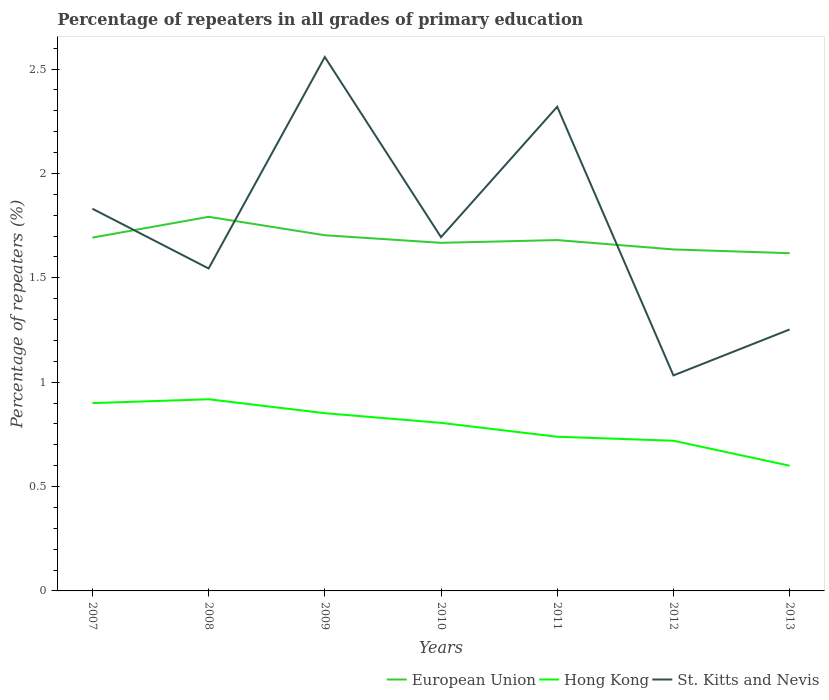Does the line corresponding to European Union intersect with the line corresponding to St. Kitts and Nevis?
Your response must be concise. Yes. Is the number of lines equal to the number of legend labels?
Give a very brief answer. Yes. Across all years, what is the maximum percentage of repeaters in St. Kitts and Nevis?
Your answer should be very brief. 1.03. What is the total percentage of repeaters in European Union in the graph?
Provide a short and direct response. 0.09. What is the difference between the highest and the second highest percentage of repeaters in European Union?
Your answer should be very brief. 0.17. How many lines are there?
Ensure brevity in your answer.  3. How many years are there in the graph?
Your answer should be very brief. 7. Where does the legend appear in the graph?
Keep it short and to the point. Bottom right. What is the title of the graph?
Offer a terse response. Percentage of repeaters in all grades of primary education. Does "Timor-Leste" appear as one of the legend labels in the graph?
Offer a terse response. No. What is the label or title of the Y-axis?
Make the answer very short. Percentage of repeaters (%). What is the Percentage of repeaters (%) in European Union in 2007?
Keep it short and to the point. 1.69. What is the Percentage of repeaters (%) of Hong Kong in 2007?
Offer a terse response. 0.9. What is the Percentage of repeaters (%) in St. Kitts and Nevis in 2007?
Give a very brief answer. 1.83. What is the Percentage of repeaters (%) in European Union in 2008?
Provide a short and direct response. 1.79. What is the Percentage of repeaters (%) of Hong Kong in 2008?
Ensure brevity in your answer.  0.92. What is the Percentage of repeaters (%) of St. Kitts and Nevis in 2008?
Make the answer very short. 1.54. What is the Percentage of repeaters (%) in European Union in 2009?
Your response must be concise. 1.7. What is the Percentage of repeaters (%) in Hong Kong in 2009?
Ensure brevity in your answer.  0.85. What is the Percentage of repeaters (%) in St. Kitts and Nevis in 2009?
Keep it short and to the point. 2.56. What is the Percentage of repeaters (%) in European Union in 2010?
Provide a short and direct response. 1.67. What is the Percentage of repeaters (%) of Hong Kong in 2010?
Give a very brief answer. 0.81. What is the Percentage of repeaters (%) of St. Kitts and Nevis in 2010?
Make the answer very short. 1.69. What is the Percentage of repeaters (%) in European Union in 2011?
Give a very brief answer. 1.68. What is the Percentage of repeaters (%) in Hong Kong in 2011?
Provide a succinct answer. 0.74. What is the Percentage of repeaters (%) in St. Kitts and Nevis in 2011?
Your answer should be compact. 2.32. What is the Percentage of repeaters (%) of European Union in 2012?
Give a very brief answer. 1.64. What is the Percentage of repeaters (%) in Hong Kong in 2012?
Provide a succinct answer. 0.72. What is the Percentage of repeaters (%) in St. Kitts and Nevis in 2012?
Offer a terse response. 1.03. What is the Percentage of repeaters (%) in European Union in 2013?
Give a very brief answer. 1.62. What is the Percentage of repeaters (%) in Hong Kong in 2013?
Your response must be concise. 0.6. What is the Percentage of repeaters (%) of St. Kitts and Nevis in 2013?
Your answer should be compact. 1.25. Across all years, what is the maximum Percentage of repeaters (%) in European Union?
Your answer should be compact. 1.79. Across all years, what is the maximum Percentage of repeaters (%) in Hong Kong?
Offer a terse response. 0.92. Across all years, what is the maximum Percentage of repeaters (%) of St. Kitts and Nevis?
Your response must be concise. 2.56. Across all years, what is the minimum Percentage of repeaters (%) of European Union?
Your answer should be very brief. 1.62. Across all years, what is the minimum Percentage of repeaters (%) in Hong Kong?
Provide a short and direct response. 0.6. Across all years, what is the minimum Percentage of repeaters (%) in St. Kitts and Nevis?
Offer a terse response. 1.03. What is the total Percentage of repeaters (%) of European Union in the graph?
Provide a short and direct response. 11.79. What is the total Percentage of repeaters (%) of Hong Kong in the graph?
Your answer should be compact. 5.53. What is the total Percentage of repeaters (%) in St. Kitts and Nevis in the graph?
Offer a very short reply. 12.23. What is the difference between the Percentage of repeaters (%) in European Union in 2007 and that in 2008?
Provide a short and direct response. -0.1. What is the difference between the Percentage of repeaters (%) in Hong Kong in 2007 and that in 2008?
Offer a terse response. -0.02. What is the difference between the Percentage of repeaters (%) of St. Kitts and Nevis in 2007 and that in 2008?
Ensure brevity in your answer.  0.29. What is the difference between the Percentage of repeaters (%) of European Union in 2007 and that in 2009?
Ensure brevity in your answer.  -0.01. What is the difference between the Percentage of repeaters (%) in Hong Kong in 2007 and that in 2009?
Your answer should be compact. 0.05. What is the difference between the Percentage of repeaters (%) in St. Kitts and Nevis in 2007 and that in 2009?
Offer a terse response. -0.73. What is the difference between the Percentage of repeaters (%) of European Union in 2007 and that in 2010?
Your answer should be compact. 0.03. What is the difference between the Percentage of repeaters (%) of Hong Kong in 2007 and that in 2010?
Give a very brief answer. 0.09. What is the difference between the Percentage of repeaters (%) in St. Kitts and Nevis in 2007 and that in 2010?
Your answer should be compact. 0.14. What is the difference between the Percentage of repeaters (%) of European Union in 2007 and that in 2011?
Your answer should be very brief. 0.01. What is the difference between the Percentage of repeaters (%) in Hong Kong in 2007 and that in 2011?
Ensure brevity in your answer.  0.16. What is the difference between the Percentage of repeaters (%) in St. Kitts and Nevis in 2007 and that in 2011?
Ensure brevity in your answer.  -0.49. What is the difference between the Percentage of repeaters (%) of European Union in 2007 and that in 2012?
Your answer should be very brief. 0.06. What is the difference between the Percentage of repeaters (%) of Hong Kong in 2007 and that in 2012?
Your answer should be very brief. 0.18. What is the difference between the Percentage of repeaters (%) in St. Kitts and Nevis in 2007 and that in 2012?
Provide a short and direct response. 0.8. What is the difference between the Percentage of repeaters (%) of European Union in 2007 and that in 2013?
Your response must be concise. 0.07. What is the difference between the Percentage of repeaters (%) of Hong Kong in 2007 and that in 2013?
Your response must be concise. 0.3. What is the difference between the Percentage of repeaters (%) in St. Kitts and Nevis in 2007 and that in 2013?
Make the answer very short. 0.58. What is the difference between the Percentage of repeaters (%) in European Union in 2008 and that in 2009?
Ensure brevity in your answer.  0.09. What is the difference between the Percentage of repeaters (%) in Hong Kong in 2008 and that in 2009?
Your answer should be very brief. 0.07. What is the difference between the Percentage of repeaters (%) of St. Kitts and Nevis in 2008 and that in 2009?
Provide a succinct answer. -1.01. What is the difference between the Percentage of repeaters (%) in European Union in 2008 and that in 2010?
Your answer should be compact. 0.12. What is the difference between the Percentage of repeaters (%) in Hong Kong in 2008 and that in 2010?
Offer a terse response. 0.11. What is the difference between the Percentage of repeaters (%) in St. Kitts and Nevis in 2008 and that in 2010?
Make the answer very short. -0.15. What is the difference between the Percentage of repeaters (%) of European Union in 2008 and that in 2011?
Offer a terse response. 0.11. What is the difference between the Percentage of repeaters (%) of Hong Kong in 2008 and that in 2011?
Ensure brevity in your answer.  0.18. What is the difference between the Percentage of repeaters (%) of St. Kitts and Nevis in 2008 and that in 2011?
Keep it short and to the point. -0.77. What is the difference between the Percentage of repeaters (%) of European Union in 2008 and that in 2012?
Provide a short and direct response. 0.16. What is the difference between the Percentage of repeaters (%) in Hong Kong in 2008 and that in 2012?
Give a very brief answer. 0.2. What is the difference between the Percentage of repeaters (%) in St. Kitts and Nevis in 2008 and that in 2012?
Your response must be concise. 0.51. What is the difference between the Percentage of repeaters (%) of European Union in 2008 and that in 2013?
Ensure brevity in your answer.  0.17. What is the difference between the Percentage of repeaters (%) of Hong Kong in 2008 and that in 2013?
Your answer should be compact. 0.32. What is the difference between the Percentage of repeaters (%) in St. Kitts and Nevis in 2008 and that in 2013?
Your answer should be compact. 0.29. What is the difference between the Percentage of repeaters (%) in European Union in 2009 and that in 2010?
Make the answer very short. 0.04. What is the difference between the Percentage of repeaters (%) in Hong Kong in 2009 and that in 2010?
Your answer should be very brief. 0.05. What is the difference between the Percentage of repeaters (%) in St. Kitts and Nevis in 2009 and that in 2010?
Provide a succinct answer. 0.86. What is the difference between the Percentage of repeaters (%) of European Union in 2009 and that in 2011?
Provide a short and direct response. 0.02. What is the difference between the Percentage of repeaters (%) in Hong Kong in 2009 and that in 2011?
Provide a short and direct response. 0.11. What is the difference between the Percentage of repeaters (%) in St. Kitts and Nevis in 2009 and that in 2011?
Give a very brief answer. 0.24. What is the difference between the Percentage of repeaters (%) of European Union in 2009 and that in 2012?
Offer a very short reply. 0.07. What is the difference between the Percentage of repeaters (%) in Hong Kong in 2009 and that in 2012?
Offer a terse response. 0.13. What is the difference between the Percentage of repeaters (%) of St. Kitts and Nevis in 2009 and that in 2012?
Give a very brief answer. 1.53. What is the difference between the Percentage of repeaters (%) in European Union in 2009 and that in 2013?
Provide a succinct answer. 0.09. What is the difference between the Percentage of repeaters (%) in Hong Kong in 2009 and that in 2013?
Your answer should be very brief. 0.25. What is the difference between the Percentage of repeaters (%) in St. Kitts and Nevis in 2009 and that in 2013?
Give a very brief answer. 1.31. What is the difference between the Percentage of repeaters (%) in European Union in 2010 and that in 2011?
Provide a short and direct response. -0.01. What is the difference between the Percentage of repeaters (%) in Hong Kong in 2010 and that in 2011?
Your answer should be compact. 0.07. What is the difference between the Percentage of repeaters (%) of St. Kitts and Nevis in 2010 and that in 2011?
Ensure brevity in your answer.  -0.62. What is the difference between the Percentage of repeaters (%) in European Union in 2010 and that in 2012?
Offer a very short reply. 0.03. What is the difference between the Percentage of repeaters (%) of Hong Kong in 2010 and that in 2012?
Offer a terse response. 0.09. What is the difference between the Percentage of repeaters (%) in St. Kitts and Nevis in 2010 and that in 2012?
Offer a very short reply. 0.66. What is the difference between the Percentage of repeaters (%) in European Union in 2010 and that in 2013?
Ensure brevity in your answer.  0.05. What is the difference between the Percentage of repeaters (%) of Hong Kong in 2010 and that in 2013?
Provide a short and direct response. 0.21. What is the difference between the Percentage of repeaters (%) in St. Kitts and Nevis in 2010 and that in 2013?
Make the answer very short. 0.44. What is the difference between the Percentage of repeaters (%) of European Union in 2011 and that in 2012?
Your response must be concise. 0.04. What is the difference between the Percentage of repeaters (%) of Hong Kong in 2011 and that in 2012?
Your response must be concise. 0.02. What is the difference between the Percentage of repeaters (%) of St. Kitts and Nevis in 2011 and that in 2012?
Provide a succinct answer. 1.29. What is the difference between the Percentage of repeaters (%) in European Union in 2011 and that in 2013?
Provide a succinct answer. 0.06. What is the difference between the Percentage of repeaters (%) of Hong Kong in 2011 and that in 2013?
Provide a succinct answer. 0.14. What is the difference between the Percentage of repeaters (%) of St. Kitts and Nevis in 2011 and that in 2013?
Offer a terse response. 1.07. What is the difference between the Percentage of repeaters (%) of European Union in 2012 and that in 2013?
Your answer should be compact. 0.02. What is the difference between the Percentage of repeaters (%) of Hong Kong in 2012 and that in 2013?
Your response must be concise. 0.12. What is the difference between the Percentage of repeaters (%) in St. Kitts and Nevis in 2012 and that in 2013?
Ensure brevity in your answer.  -0.22. What is the difference between the Percentage of repeaters (%) of European Union in 2007 and the Percentage of repeaters (%) of Hong Kong in 2008?
Your response must be concise. 0.77. What is the difference between the Percentage of repeaters (%) of European Union in 2007 and the Percentage of repeaters (%) of St. Kitts and Nevis in 2008?
Give a very brief answer. 0.15. What is the difference between the Percentage of repeaters (%) in Hong Kong in 2007 and the Percentage of repeaters (%) in St. Kitts and Nevis in 2008?
Give a very brief answer. -0.65. What is the difference between the Percentage of repeaters (%) in European Union in 2007 and the Percentage of repeaters (%) in Hong Kong in 2009?
Keep it short and to the point. 0.84. What is the difference between the Percentage of repeaters (%) of European Union in 2007 and the Percentage of repeaters (%) of St. Kitts and Nevis in 2009?
Your answer should be compact. -0.87. What is the difference between the Percentage of repeaters (%) of Hong Kong in 2007 and the Percentage of repeaters (%) of St. Kitts and Nevis in 2009?
Your answer should be compact. -1.66. What is the difference between the Percentage of repeaters (%) of European Union in 2007 and the Percentage of repeaters (%) of Hong Kong in 2010?
Offer a very short reply. 0.89. What is the difference between the Percentage of repeaters (%) in European Union in 2007 and the Percentage of repeaters (%) in St. Kitts and Nevis in 2010?
Offer a very short reply. -0. What is the difference between the Percentage of repeaters (%) of Hong Kong in 2007 and the Percentage of repeaters (%) of St. Kitts and Nevis in 2010?
Ensure brevity in your answer.  -0.8. What is the difference between the Percentage of repeaters (%) of European Union in 2007 and the Percentage of repeaters (%) of Hong Kong in 2011?
Your answer should be very brief. 0.95. What is the difference between the Percentage of repeaters (%) of European Union in 2007 and the Percentage of repeaters (%) of St. Kitts and Nevis in 2011?
Provide a succinct answer. -0.63. What is the difference between the Percentage of repeaters (%) of Hong Kong in 2007 and the Percentage of repeaters (%) of St. Kitts and Nevis in 2011?
Keep it short and to the point. -1.42. What is the difference between the Percentage of repeaters (%) in European Union in 2007 and the Percentage of repeaters (%) in St. Kitts and Nevis in 2012?
Keep it short and to the point. 0.66. What is the difference between the Percentage of repeaters (%) of Hong Kong in 2007 and the Percentage of repeaters (%) of St. Kitts and Nevis in 2012?
Ensure brevity in your answer.  -0.13. What is the difference between the Percentage of repeaters (%) in European Union in 2007 and the Percentage of repeaters (%) in Hong Kong in 2013?
Your answer should be compact. 1.09. What is the difference between the Percentage of repeaters (%) of European Union in 2007 and the Percentage of repeaters (%) of St. Kitts and Nevis in 2013?
Your answer should be compact. 0.44. What is the difference between the Percentage of repeaters (%) in Hong Kong in 2007 and the Percentage of repeaters (%) in St. Kitts and Nevis in 2013?
Your response must be concise. -0.35. What is the difference between the Percentage of repeaters (%) in European Union in 2008 and the Percentage of repeaters (%) in Hong Kong in 2009?
Provide a short and direct response. 0.94. What is the difference between the Percentage of repeaters (%) of European Union in 2008 and the Percentage of repeaters (%) of St. Kitts and Nevis in 2009?
Your response must be concise. -0.77. What is the difference between the Percentage of repeaters (%) of Hong Kong in 2008 and the Percentage of repeaters (%) of St. Kitts and Nevis in 2009?
Offer a terse response. -1.64. What is the difference between the Percentage of repeaters (%) in European Union in 2008 and the Percentage of repeaters (%) in Hong Kong in 2010?
Provide a short and direct response. 0.99. What is the difference between the Percentage of repeaters (%) in European Union in 2008 and the Percentage of repeaters (%) in St. Kitts and Nevis in 2010?
Give a very brief answer. 0.1. What is the difference between the Percentage of repeaters (%) of Hong Kong in 2008 and the Percentage of repeaters (%) of St. Kitts and Nevis in 2010?
Provide a succinct answer. -0.78. What is the difference between the Percentage of repeaters (%) of European Union in 2008 and the Percentage of repeaters (%) of Hong Kong in 2011?
Ensure brevity in your answer.  1.05. What is the difference between the Percentage of repeaters (%) in European Union in 2008 and the Percentage of repeaters (%) in St. Kitts and Nevis in 2011?
Give a very brief answer. -0.53. What is the difference between the Percentage of repeaters (%) of Hong Kong in 2008 and the Percentage of repeaters (%) of St. Kitts and Nevis in 2011?
Make the answer very short. -1.4. What is the difference between the Percentage of repeaters (%) of European Union in 2008 and the Percentage of repeaters (%) of Hong Kong in 2012?
Keep it short and to the point. 1.07. What is the difference between the Percentage of repeaters (%) of European Union in 2008 and the Percentage of repeaters (%) of St. Kitts and Nevis in 2012?
Ensure brevity in your answer.  0.76. What is the difference between the Percentage of repeaters (%) of Hong Kong in 2008 and the Percentage of repeaters (%) of St. Kitts and Nevis in 2012?
Provide a short and direct response. -0.11. What is the difference between the Percentage of repeaters (%) of European Union in 2008 and the Percentage of repeaters (%) of Hong Kong in 2013?
Ensure brevity in your answer.  1.19. What is the difference between the Percentage of repeaters (%) in European Union in 2008 and the Percentage of repeaters (%) in St. Kitts and Nevis in 2013?
Your answer should be compact. 0.54. What is the difference between the Percentage of repeaters (%) in Hong Kong in 2008 and the Percentage of repeaters (%) in St. Kitts and Nevis in 2013?
Offer a very short reply. -0.33. What is the difference between the Percentage of repeaters (%) in European Union in 2009 and the Percentage of repeaters (%) in Hong Kong in 2010?
Provide a succinct answer. 0.9. What is the difference between the Percentage of repeaters (%) of European Union in 2009 and the Percentage of repeaters (%) of St. Kitts and Nevis in 2010?
Keep it short and to the point. 0.01. What is the difference between the Percentage of repeaters (%) in Hong Kong in 2009 and the Percentage of repeaters (%) in St. Kitts and Nevis in 2010?
Offer a very short reply. -0.84. What is the difference between the Percentage of repeaters (%) of European Union in 2009 and the Percentage of repeaters (%) of Hong Kong in 2011?
Your response must be concise. 0.97. What is the difference between the Percentage of repeaters (%) in European Union in 2009 and the Percentage of repeaters (%) in St. Kitts and Nevis in 2011?
Your response must be concise. -0.62. What is the difference between the Percentage of repeaters (%) in Hong Kong in 2009 and the Percentage of repeaters (%) in St. Kitts and Nevis in 2011?
Give a very brief answer. -1.47. What is the difference between the Percentage of repeaters (%) of European Union in 2009 and the Percentage of repeaters (%) of Hong Kong in 2012?
Make the answer very short. 0.98. What is the difference between the Percentage of repeaters (%) in European Union in 2009 and the Percentage of repeaters (%) in St. Kitts and Nevis in 2012?
Ensure brevity in your answer.  0.67. What is the difference between the Percentage of repeaters (%) of Hong Kong in 2009 and the Percentage of repeaters (%) of St. Kitts and Nevis in 2012?
Keep it short and to the point. -0.18. What is the difference between the Percentage of repeaters (%) in European Union in 2009 and the Percentage of repeaters (%) in Hong Kong in 2013?
Provide a succinct answer. 1.1. What is the difference between the Percentage of repeaters (%) in European Union in 2009 and the Percentage of repeaters (%) in St. Kitts and Nevis in 2013?
Give a very brief answer. 0.45. What is the difference between the Percentage of repeaters (%) of Hong Kong in 2009 and the Percentage of repeaters (%) of St. Kitts and Nevis in 2013?
Offer a terse response. -0.4. What is the difference between the Percentage of repeaters (%) in European Union in 2010 and the Percentage of repeaters (%) in Hong Kong in 2011?
Provide a short and direct response. 0.93. What is the difference between the Percentage of repeaters (%) in European Union in 2010 and the Percentage of repeaters (%) in St. Kitts and Nevis in 2011?
Offer a very short reply. -0.65. What is the difference between the Percentage of repeaters (%) of Hong Kong in 2010 and the Percentage of repeaters (%) of St. Kitts and Nevis in 2011?
Keep it short and to the point. -1.51. What is the difference between the Percentage of repeaters (%) in European Union in 2010 and the Percentage of repeaters (%) in Hong Kong in 2012?
Make the answer very short. 0.95. What is the difference between the Percentage of repeaters (%) in European Union in 2010 and the Percentage of repeaters (%) in St. Kitts and Nevis in 2012?
Make the answer very short. 0.64. What is the difference between the Percentage of repeaters (%) of Hong Kong in 2010 and the Percentage of repeaters (%) of St. Kitts and Nevis in 2012?
Your answer should be compact. -0.23. What is the difference between the Percentage of repeaters (%) of European Union in 2010 and the Percentage of repeaters (%) of Hong Kong in 2013?
Offer a terse response. 1.07. What is the difference between the Percentage of repeaters (%) in European Union in 2010 and the Percentage of repeaters (%) in St. Kitts and Nevis in 2013?
Your answer should be compact. 0.41. What is the difference between the Percentage of repeaters (%) in Hong Kong in 2010 and the Percentage of repeaters (%) in St. Kitts and Nevis in 2013?
Your answer should be compact. -0.45. What is the difference between the Percentage of repeaters (%) of European Union in 2011 and the Percentage of repeaters (%) of Hong Kong in 2012?
Make the answer very short. 0.96. What is the difference between the Percentage of repeaters (%) in European Union in 2011 and the Percentage of repeaters (%) in St. Kitts and Nevis in 2012?
Offer a very short reply. 0.65. What is the difference between the Percentage of repeaters (%) of Hong Kong in 2011 and the Percentage of repeaters (%) of St. Kitts and Nevis in 2012?
Keep it short and to the point. -0.29. What is the difference between the Percentage of repeaters (%) of European Union in 2011 and the Percentage of repeaters (%) of Hong Kong in 2013?
Offer a very short reply. 1.08. What is the difference between the Percentage of repeaters (%) of European Union in 2011 and the Percentage of repeaters (%) of St. Kitts and Nevis in 2013?
Your answer should be very brief. 0.43. What is the difference between the Percentage of repeaters (%) in Hong Kong in 2011 and the Percentage of repeaters (%) in St. Kitts and Nevis in 2013?
Give a very brief answer. -0.51. What is the difference between the Percentage of repeaters (%) in European Union in 2012 and the Percentage of repeaters (%) in Hong Kong in 2013?
Your response must be concise. 1.04. What is the difference between the Percentage of repeaters (%) of European Union in 2012 and the Percentage of repeaters (%) of St. Kitts and Nevis in 2013?
Ensure brevity in your answer.  0.38. What is the difference between the Percentage of repeaters (%) of Hong Kong in 2012 and the Percentage of repeaters (%) of St. Kitts and Nevis in 2013?
Give a very brief answer. -0.53. What is the average Percentage of repeaters (%) of European Union per year?
Your answer should be very brief. 1.68. What is the average Percentage of repeaters (%) of Hong Kong per year?
Offer a terse response. 0.79. What is the average Percentage of repeaters (%) in St. Kitts and Nevis per year?
Your response must be concise. 1.75. In the year 2007, what is the difference between the Percentage of repeaters (%) of European Union and Percentage of repeaters (%) of Hong Kong?
Make the answer very short. 0.79. In the year 2007, what is the difference between the Percentage of repeaters (%) in European Union and Percentage of repeaters (%) in St. Kitts and Nevis?
Give a very brief answer. -0.14. In the year 2007, what is the difference between the Percentage of repeaters (%) of Hong Kong and Percentage of repeaters (%) of St. Kitts and Nevis?
Make the answer very short. -0.93. In the year 2008, what is the difference between the Percentage of repeaters (%) in European Union and Percentage of repeaters (%) in Hong Kong?
Keep it short and to the point. 0.87. In the year 2008, what is the difference between the Percentage of repeaters (%) of European Union and Percentage of repeaters (%) of St. Kitts and Nevis?
Your answer should be very brief. 0.25. In the year 2008, what is the difference between the Percentage of repeaters (%) of Hong Kong and Percentage of repeaters (%) of St. Kitts and Nevis?
Your answer should be very brief. -0.63. In the year 2009, what is the difference between the Percentage of repeaters (%) in European Union and Percentage of repeaters (%) in Hong Kong?
Offer a very short reply. 0.85. In the year 2009, what is the difference between the Percentage of repeaters (%) of European Union and Percentage of repeaters (%) of St. Kitts and Nevis?
Ensure brevity in your answer.  -0.85. In the year 2009, what is the difference between the Percentage of repeaters (%) in Hong Kong and Percentage of repeaters (%) in St. Kitts and Nevis?
Your answer should be very brief. -1.71. In the year 2010, what is the difference between the Percentage of repeaters (%) in European Union and Percentage of repeaters (%) in Hong Kong?
Provide a succinct answer. 0.86. In the year 2010, what is the difference between the Percentage of repeaters (%) of European Union and Percentage of repeaters (%) of St. Kitts and Nevis?
Offer a very short reply. -0.03. In the year 2010, what is the difference between the Percentage of repeaters (%) of Hong Kong and Percentage of repeaters (%) of St. Kitts and Nevis?
Your answer should be very brief. -0.89. In the year 2011, what is the difference between the Percentage of repeaters (%) in European Union and Percentage of repeaters (%) in Hong Kong?
Keep it short and to the point. 0.94. In the year 2011, what is the difference between the Percentage of repeaters (%) of European Union and Percentage of repeaters (%) of St. Kitts and Nevis?
Provide a short and direct response. -0.64. In the year 2011, what is the difference between the Percentage of repeaters (%) of Hong Kong and Percentage of repeaters (%) of St. Kitts and Nevis?
Give a very brief answer. -1.58. In the year 2012, what is the difference between the Percentage of repeaters (%) of European Union and Percentage of repeaters (%) of Hong Kong?
Provide a short and direct response. 0.92. In the year 2012, what is the difference between the Percentage of repeaters (%) of European Union and Percentage of repeaters (%) of St. Kitts and Nevis?
Ensure brevity in your answer.  0.6. In the year 2012, what is the difference between the Percentage of repeaters (%) in Hong Kong and Percentage of repeaters (%) in St. Kitts and Nevis?
Provide a succinct answer. -0.31. In the year 2013, what is the difference between the Percentage of repeaters (%) of European Union and Percentage of repeaters (%) of Hong Kong?
Provide a succinct answer. 1.02. In the year 2013, what is the difference between the Percentage of repeaters (%) of European Union and Percentage of repeaters (%) of St. Kitts and Nevis?
Keep it short and to the point. 0.37. In the year 2013, what is the difference between the Percentage of repeaters (%) in Hong Kong and Percentage of repeaters (%) in St. Kitts and Nevis?
Offer a terse response. -0.65. What is the ratio of the Percentage of repeaters (%) in Hong Kong in 2007 to that in 2008?
Your answer should be compact. 0.98. What is the ratio of the Percentage of repeaters (%) in St. Kitts and Nevis in 2007 to that in 2008?
Make the answer very short. 1.19. What is the ratio of the Percentage of repeaters (%) of Hong Kong in 2007 to that in 2009?
Ensure brevity in your answer.  1.06. What is the ratio of the Percentage of repeaters (%) in St. Kitts and Nevis in 2007 to that in 2009?
Your answer should be very brief. 0.72. What is the ratio of the Percentage of repeaters (%) in European Union in 2007 to that in 2010?
Your response must be concise. 1.01. What is the ratio of the Percentage of repeaters (%) in Hong Kong in 2007 to that in 2010?
Offer a very short reply. 1.12. What is the ratio of the Percentage of repeaters (%) of St. Kitts and Nevis in 2007 to that in 2010?
Provide a short and direct response. 1.08. What is the ratio of the Percentage of repeaters (%) in Hong Kong in 2007 to that in 2011?
Offer a terse response. 1.22. What is the ratio of the Percentage of repeaters (%) of St. Kitts and Nevis in 2007 to that in 2011?
Ensure brevity in your answer.  0.79. What is the ratio of the Percentage of repeaters (%) of European Union in 2007 to that in 2012?
Provide a short and direct response. 1.03. What is the ratio of the Percentage of repeaters (%) in Hong Kong in 2007 to that in 2012?
Provide a succinct answer. 1.25. What is the ratio of the Percentage of repeaters (%) in St. Kitts and Nevis in 2007 to that in 2012?
Offer a terse response. 1.77. What is the ratio of the Percentage of repeaters (%) of European Union in 2007 to that in 2013?
Give a very brief answer. 1.05. What is the ratio of the Percentage of repeaters (%) of Hong Kong in 2007 to that in 2013?
Ensure brevity in your answer.  1.5. What is the ratio of the Percentage of repeaters (%) of St. Kitts and Nevis in 2007 to that in 2013?
Offer a terse response. 1.46. What is the ratio of the Percentage of repeaters (%) in European Union in 2008 to that in 2009?
Provide a succinct answer. 1.05. What is the ratio of the Percentage of repeaters (%) of Hong Kong in 2008 to that in 2009?
Your answer should be very brief. 1.08. What is the ratio of the Percentage of repeaters (%) of St. Kitts and Nevis in 2008 to that in 2009?
Ensure brevity in your answer.  0.6. What is the ratio of the Percentage of repeaters (%) in European Union in 2008 to that in 2010?
Offer a terse response. 1.07. What is the ratio of the Percentage of repeaters (%) of Hong Kong in 2008 to that in 2010?
Your answer should be compact. 1.14. What is the ratio of the Percentage of repeaters (%) in St. Kitts and Nevis in 2008 to that in 2010?
Provide a succinct answer. 0.91. What is the ratio of the Percentage of repeaters (%) in European Union in 2008 to that in 2011?
Your answer should be very brief. 1.07. What is the ratio of the Percentage of repeaters (%) in Hong Kong in 2008 to that in 2011?
Offer a terse response. 1.24. What is the ratio of the Percentage of repeaters (%) of St. Kitts and Nevis in 2008 to that in 2011?
Give a very brief answer. 0.67. What is the ratio of the Percentage of repeaters (%) in European Union in 2008 to that in 2012?
Offer a terse response. 1.1. What is the ratio of the Percentage of repeaters (%) of Hong Kong in 2008 to that in 2012?
Provide a short and direct response. 1.28. What is the ratio of the Percentage of repeaters (%) of St. Kitts and Nevis in 2008 to that in 2012?
Offer a terse response. 1.5. What is the ratio of the Percentage of repeaters (%) in European Union in 2008 to that in 2013?
Provide a succinct answer. 1.11. What is the ratio of the Percentage of repeaters (%) of Hong Kong in 2008 to that in 2013?
Make the answer very short. 1.53. What is the ratio of the Percentage of repeaters (%) in St. Kitts and Nevis in 2008 to that in 2013?
Provide a short and direct response. 1.23. What is the ratio of the Percentage of repeaters (%) of European Union in 2009 to that in 2010?
Offer a very short reply. 1.02. What is the ratio of the Percentage of repeaters (%) in Hong Kong in 2009 to that in 2010?
Make the answer very short. 1.06. What is the ratio of the Percentage of repeaters (%) of St. Kitts and Nevis in 2009 to that in 2010?
Offer a terse response. 1.51. What is the ratio of the Percentage of repeaters (%) of European Union in 2009 to that in 2011?
Offer a terse response. 1.01. What is the ratio of the Percentage of repeaters (%) in Hong Kong in 2009 to that in 2011?
Offer a terse response. 1.15. What is the ratio of the Percentage of repeaters (%) of St. Kitts and Nevis in 2009 to that in 2011?
Your answer should be very brief. 1.1. What is the ratio of the Percentage of repeaters (%) in European Union in 2009 to that in 2012?
Provide a short and direct response. 1.04. What is the ratio of the Percentage of repeaters (%) in Hong Kong in 2009 to that in 2012?
Ensure brevity in your answer.  1.18. What is the ratio of the Percentage of repeaters (%) of St. Kitts and Nevis in 2009 to that in 2012?
Offer a terse response. 2.48. What is the ratio of the Percentage of repeaters (%) in European Union in 2009 to that in 2013?
Make the answer very short. 1.05. What is the ratio of the Percentage of repeaters (%) in Hong Kong in 2009 to that in 2013?
Provide a short and direct response. 1.42. What is the ratio of the Percentage of repeaters (%) of St. Kitts and Nevis in 2009 to that in 2013?
Give a very brief answer. 2.04. What is the ratio of the Percentage of repeaters (%) in European Union in 2010 to that in 2011?
Your answer should be compact. 0.99. What is the ratio of the Percentage of repeaters (%) in Hong Kong in 2010 to that in 2011?
Offer a very short reply. 1.09. What is the ratio of the Percentage of repeaters (%) in St. Kitts and Nevis in 2010 to that in 2011?
Make the answer very short. 0.73. What is the ratio of the Percentage of repeaters (%) of European Union in 2010 to that in 2012?
Give a very brief answer. 1.02. What is the ratio of the Percentage of repeaters (%) in Hong Kong in 2010 to that in 2012?
Ensure brevity in your answer.  1.12. What is the ratio of the Percentage of repeaters (%) of St. Kitts and Nevis in 2010 to that in 2012?
Offer a very short reply. 1.64. What is the ratio of the Percentage of repeaters (%) of European Union in 2010 to that in 2013?
Your answer should be compact. 1.03. What is the ratio of the Percentage of repeaters (%) in Hong Kong in 2010 to that in 2013?
Make the answer very short. 1.34. What is the ratio of the Percentage of repeaters (%) in St. Kitts and Nevis in 2010 to that in 2013?
Make the answer very short. 1.35. What is the ratio of the Percentage of repeaters (%) of European Union in 2011 to that in 2012?
Your answer should be very brief. 1.03. What is the ratio of the Percentage of repeaters (%) in Hong Kong in 2011 to that in 2012?
Your answer should be compact. 1.03. What is the ratio of the Percentage of repeaters (%) in St. Kitts and Nevis in 2011 to that in 2012?
Ensure brevity in your answer.  2.25. What is the ratio of the Percentage of repeaters (%) of European Union in 2011 to that in 2013?
Your answer should be very brief. 1.04. What is the ratio of the Percentage of repeaters (%) in Hong Kong in 2011 to that in 2013?
Keep it short and to the point. 1.23. What is the ratio of the Percentage of repeaters (%) of St. Kitts and Nevis in 2011 to that in 2013?
Provide a short and direct response. 1.85. What is the ratio of the Percentage of repeaters (%) in European Union in 2012 to that in 2013?
Offer a very short reply. 1.01. What is the ratio of the Percentage of repeaters (%) of Hong Kong in 2012 to that in 2013?
Ensure brevity in your answer.  1.2. What is the ratio of the Percentage of repeaters (%) of St. Kitts and Nevis in 2012 to that in 2013?
Offer a very short reply. 0.82. What is the difference between the highest and the second highest Percentage of repeaters (%) of European Union?
Give a very brief answer. 0.09. What is the difference between the highest and the second highest Percentage of repeaters (%) in Hong Kong?
Make the answer very short. 0.02. What is the difference between the highest and the second highest Percentage of repeaters (%) of St. Kitts and Nevis?
Make the answer very short. 0.24. What is the difference between the highest and the lowest Percentage of repeaters (%) of European Union?
Provide a succinct answer. 0.17. What is the difference between the highest and the lowest Percentage of repeaters (%) of Hong Kong?
Provide a succinct answer. 0.32. What is the difference between the highest and the lowest Percentage of repeaters (%) of St. Kitts and Nevis?
Offer a terse response. 1.53. 